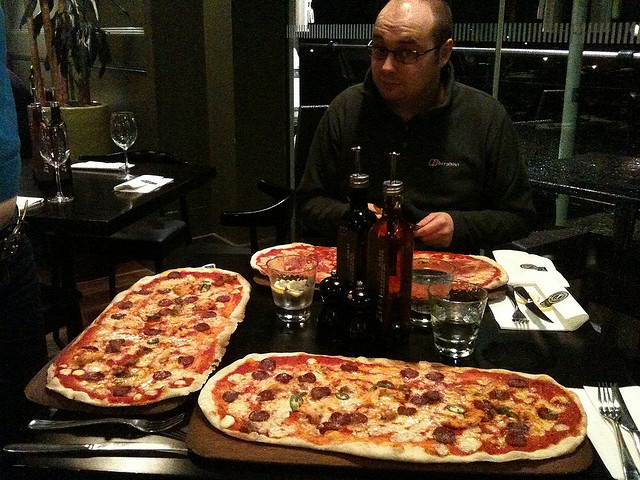Describe the objects in this image and their specific colors. I can see dining table in darkgreen, black, tan, and maroon tones, pizza in darkgreen, tan, khaki, brown, and maroon tones, people in darkgreen, black, maroon, tan, and brown tones, pizza in darkgreen, tan, and brown tones, and people in darkgreen, black, darkblue, blue, and maroon tones in this image. 